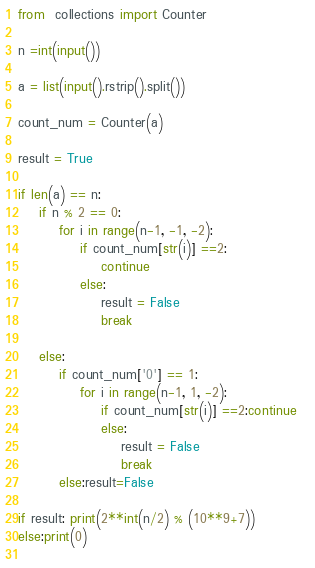<code> <loc_0><loc_0><loc_500><loc_500><_Python_>from  collections import Counter

n =int(input())

a = list(input().rstrip().split())

count_num = Counter(a)

result = True

if len(a) == n:
    if n % 2 == 0:
        for i in range(n-1, -1, -2):
            if count_num[str(i)] ==2:
                continue
            else:
                result = False
                break

    else:
        if count_num['0'] == 1:
            for i in range(n-1, 1, -2):                
                if count_num[str(i)] ==2:continue
                else:
                    result = False
                    break
        else:result=False

if result: print(2**int(n/2) % (10**9+7))
else:print(0)
  </code> 